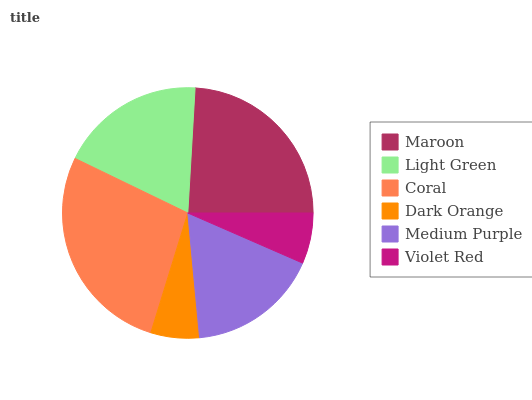Is Dark Orange the minimum?
Answer yes or no. Yes. Is Coral the maximum?
Answer yes or no. Yes. Is Light Green the minimum?
Answer yes or no. No. Is Light Green the maximum?
Answer yes or no. No. Is Maroon greater than Light Green?
Answer yes or no. Yes. Is Light Green less than Maroon?
Answer yes or no. Yes. Is Light Green greater than Maroon?
Answer yes or no. No. Is Maroon less than Light Green?
Answer yes or no. No. Is Light Green the high median?
Answer yes or no. Yes. Is Medium Purple the low median?
Answer yes or no. Yes. Is Medium Purple the high median?
Answer yes or no. No. Is Violet Red the low median?
Answer yes or no. No. 